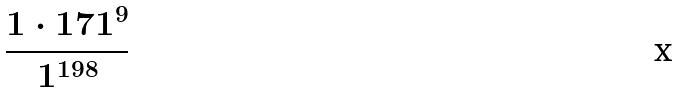<formula> <loc_0><loc_0><loc_500><loc_500>\frac { 1 \cdot 1 7 1 ^ { 9 } } { 1 ^ { 1 9 8 } }</formula> 